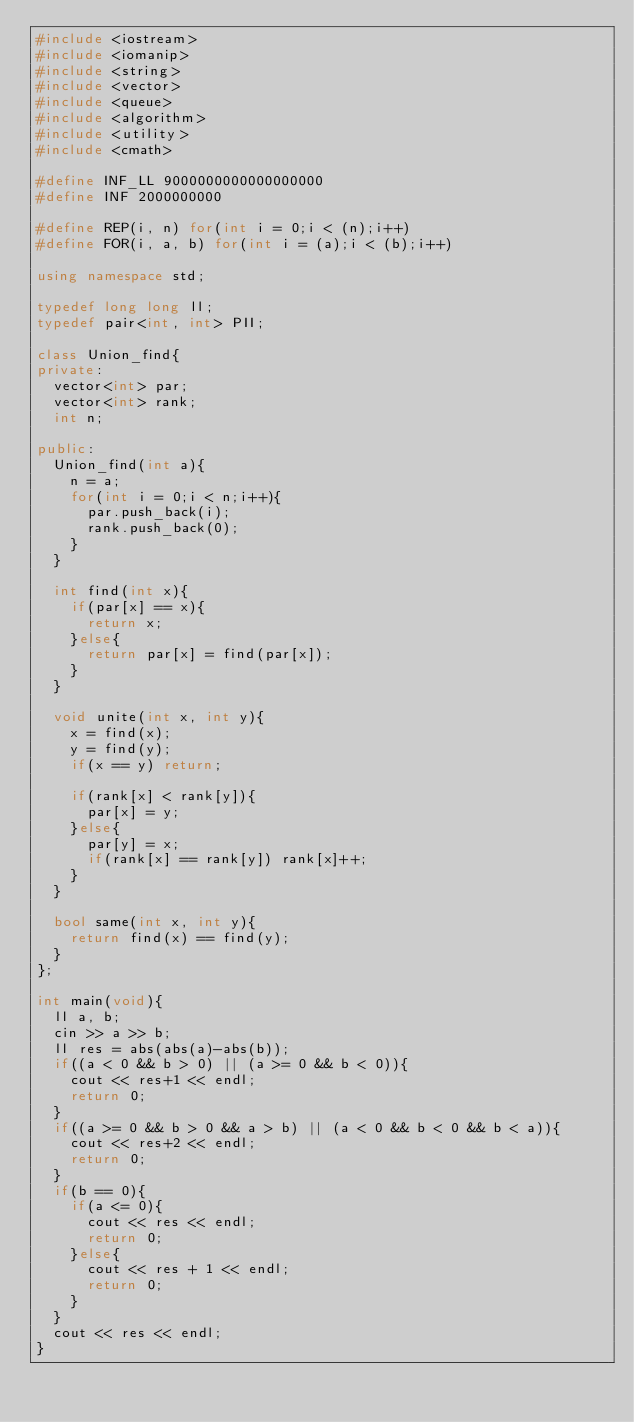<code> <loc_0><loc_0><loc_500><loc_500><_C++_>#include <iostream>
#include <iomanip>
#include <string>
#include <vector>
#include <queue>
#include <algorithm>
#include <utility>
#include <cmath>

#define INF_LL 9000000000000000000
#define INF 2000000000

#define REP(i, n) for(int i = 0;i < (n);i++)
#define FOR(i, a, b) for(int i = (a);i < (b);i++)

using namespace std;

typedef long long ll;
typedef pair<int, int> PII;

class Union_find{
private:
	vector<int> par;
	vector<int> rank;
	int n;

public:
	Union_find(int a){
		n = a;
		for(int i = 0;i < n;i++){
			par.push_back(i);
			rank.push_back(0);
		}
	}

	int find(int x){
		if(par[x] == x){
			return x;
		}else{
			return par[x] = find(par[x]);
		}
	}

	void unite(int x, int y){
		x = find(x);
		y = find(y);
		if(x == y) return;

		if(rank[x] < rank[y]){
			par[x] = y;
		}else{
			par[y] = x;
			if(rank[x] == rank[y]) rank[x]++;
		}
	}

	bool same(int x, int y){
		return find(x) == find(y);
	}
};

int main(void){
	ll a, b;
	cin >> a >> b;
	ll res = abs(abs(a)-abs(b));
	if((a < 0 && b > 0) || (a >= 0 && b < 0)){
		cout << res+1 << endl;
		return 0;
	}
	if((a >= 0 && b > 0 && a > b) || (a < 0 && b < 0 && b < a)){
		cout << res+2 << endl;
		return 0;
	}
	if(b == 0){
		if(a <= 0){
			cout << res << endl;
			return 0;
		}else{
			cout << res + 1 << endl;
			return 0;
		}
	}
	cout << res << endl;
}
</code> 